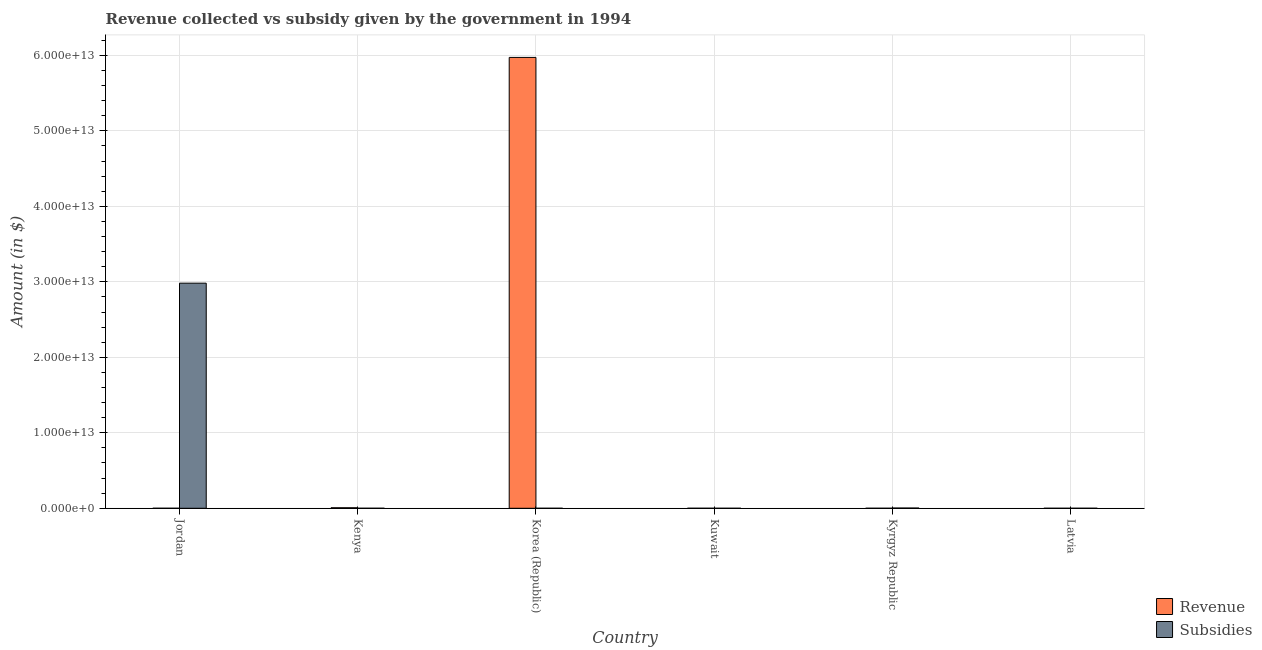How many different coloured bars are there?
Provide a succinct answer. 2. How many groups of bars are there?
Give a very brief answer. 6. What is the label of the 2nd group of bars from the left?
Your answer should be very brief. Kenya. In how many cases, is the number of bars for a given country not equal to the number of legend labels?
Offer a very short reply. 0. What is the amount of subsidies given in Korea (Republic)?
Provide a succinct answer. 3.35e+08. Across all countries, what is the maximum amount of subsidies given?
Provide a short and direct response. 2.98e+13. In which country was the amount of subsidies given maximum?
Make the answer very short. Jordan. In which country was the amount of subsidies given minimum?
Make the answer very short. Kuwait. What is the total amount of revenue collected in the graph?
Keep it short and to the point. 5.98e+13. What is the difference between the amount of subsidies given in Kuwait and that in Latvia?
Ensure brevity in your answer.  -5.97e+08. What is the difference between the amount of revenue collected in Jordan and the amount of subsidies given in Latvia?
Ensure brevity in your answer.  5.57e+08. What is the average amount of subsidies given per country?
Provide a succinct answer. 4.98e+12. What is the difference between the amount of revenue collected and amount of subsidies given in Kuwait?
Offer a terse response. 2.54e+09. In how many countries, is the amount of revenue collected greater than 34000000000000 $?
Offer a very short reply. 1. What is the ratio of the amount of revenue collected in Jordan to that in Kyrgyz Republic?
Ensure brevity in your answer.  0.62. Is the difference between the amount of subsidies given in Kenya and Korea (Republic) greater than the difference between the amount of revenue collected in Kenya and Korea (Republic)?
Ensure brevity in your answer.  Yes. What is the difference between the highest and the second highest amount of subsidies given?
Your answer should be compact. 2.98e+13. What is the difference between the highest and the lowest amount of revenue collected?
Ensure brevity in your answer.  5.97e+13. In how many countries, is the amount of revenue collected greater than the average amount of revenue collected taken over all countries?
Offer a very short reply. 1. Is the sum of the amount of revenue collected in Korea (Republic) and Kuwait greater than the maximum amount of subsidies given across all countries?
Offer a terse response. Yes. What does the 1st bar from the left in Kyrgyz Republic represents?
Provide a succinct answer. Revenue. What does the 2nd bar from the right in Latvia represents?
Provide a short and direct response. Revenue. Are all the bars in the graph horizontal?
Offer a very short reply. No. What is the difference between two consecutive major ticks on the Y-axis?
Your response must be concise. 1.00e+13. Does the graph contain grids?
Your response must be concise. Yes. How many legend labels are there?
Provide a succinct answer. 2. How are the legend labels stacked?
Your answer should be very brief. Vertical. What is the title of the graph?
Your answer should be very brief. Revenue collected vs subsidy given by the government in 1994. Does "Drinking water services" appear as one of the legend labels in the graph?
Your response must be concise. No. What is the label or title of the X-axis?
Give a very brief answer. Country. What is the label or title of the Y-axis?
Give a very brief answer. Amount (in $). What is the Amount (in $) in Revenue in Jordan?
Give a very brief answer. 1.16e+09. What is the Amount (in $) of Subsidies in Jordan?
Make the answer very short. 2.98e+13. What is the Amount (in $) in Revenue in Kenya?
Offer a terse response. 6.74e+1. What is the Amount (in $) of Subsidies in Kenya?
Keep it short and to the point. 8.19e+08. What is the Amount (in $) in Revenue in Korea (Republic)?
Keep it short and to the point. 5.97e+13. What is the Amount (in $) of Subsidies in Korea (Republic)?
Make the answer very short. 3.35e+08. What is the Amount (in $) of Revenue in Kuwait?
Make the answer very short. 2.54e+09. What is the Amount (in $) of Revenue in Kyrgyz Republic?
Provide a succinct answer. 1.87e+09. What is the Amount (in $) of Subsidies in Kyrgyz Republic?
Make the answer very short. 3.03e+1. What is the Amount (in $) in Revenue in Latvia?
Make the answer very short. 5.22e+08. What is the Amount (in $) in Subsidies in Latvia?
Make the answer very short. 6.05e+08. Across all countries, what is the maximum Amount (in $) in Revenue?
Provide a succinct answer. 5.97e+13. Across all countries, what is the maximum Amount (in $) of Subsidies?
Your answer should be compact. 2.98e+13. Across all countries, what is the minimum Amount (in $) in Revenue?
Make the answer very short. 5.22e+08. What is the total Amount (in $) in Revenue in the graph?
Provide a short and direct response. 5.98e+13. What is the total Amount (in $) of Subsidies in the graph?
Provide a succinct answer. 2.99e+13. What is the difference between the Amount (in $) of Revenue in Jordan and that in Kenya?
Your response must be concise. -6.62e+1. What is the difference between the Amount (in $) in Subsidies in Jordan and that in Kenya?
Your response must be concise. 2.98e+13. What is the difference between the Amount (in $) in Revenue in Jordan and that in Korea (Republic)?
Give a very brief answer. -5.97e+13. What is the difference between the Amount (in $) of Subsidies in Jordan and that in Korea (Republic)?
Offer a terse response. 2.98e+13. What is the difference between the Amount (in $) in Revenue in Jordan and that in Kuwait?
Give a very brief answer. -1.38e+09. What is the difference between the Amount (in $) in Subsidies in Jordan and that in Kuwait?
Offer a very short reply. 2.98e+13. What is the difference between the Amount (in $) in Revenue in Jordan and that in Kyrgyz Republic?
Give a very brief answer. -7.10e+08. What is the difference between the Amount (in $) of Subsidies in Jordan and that in Kyrgyz Republic?
Provide a succinct answer. 2.98e+13. What is the difference between the Amount (in $) of Revenue in Jordan and that in Latvia?
Give a very brief answer. 6.40e+08. What is the difference between the Amount (in $) of Subsidies in Jordan and that in Latvia?
Ensure brevity in your answer.  2.98e+13. What is the difference between the Amount (in $) of Revenue in Kenya and that in Korea (Republic)?
Ensure brevity in your answer.  -5.97e+13. What is the difference between the Amount (in $) of Subsidies in Kenya and that in Korea (Republic)?
Keep it short and to the point. 4.84e+08. What is the difference between the Amount (in $) in Revenue in Kenya and that in Kuwait?
Ensure brevity in your answer.  6.48e+1. What is the difference between the Amount (in $) in Subsidies in Kenya and that in Kuwait?
Keep it short and to the point. 8.11e+08. What is the difference between the Amount (in $) of Revenue in Kenya and that in Kyrgyz Republic?
Keep it short and to the point. 6.55e+1. What is the difference between the Amount (in $) of Subsidies in Kenya and that in Kyrgyz Republic?
Your response must be concise. -2.94e+1. What is the difference between the Amount (in $) of Revenue in Kenya and that in Latvia?
Offer a very short reply. 6.68e+1. What is the difference between the Amount (in $) in Subsidies in Kenya and that in Latvia?
Keep it short and to the point. 2.14e+08. What is the difference between the Amount (in $) in Revenue in Korea (Republic) and that in Kuwait?
Make the answer very short. 5.97e+13. What is the difference between the Amount (in $) in Subsidies in Korea (Republic) and that in Kuwait?
Make the answer very short. 3.27e+08. What is the difference between the Amount (in $) of Revenue in Korea (Republic) and that in Kyrgyz Republic?
Your answer should be very brief. 5.97e+13. What is the difference between the Amount (in $) of Subsidies in Korea (Republic) and that in Kyrgyz Republic?
Your response must be concise. -2.99e+1. What is the difference between the Amount (in $) of Revenue in Korea (Republic) and that in Latvia?
Your response must be concise. 5.97e+13. What is the difference between the Amount (in $) in Subsidies in Korea (Republic) and that in Latvia?
Give a very brief answer. -2.70e+08. What is the difference between the Amount (in $) in Revenue in Kuwait and that in Kyrgyz Republic?
Offer a very short reply. 6.73e+08. What is the difference between the Amount (in $) of Subsidies in Kuwait and that in Kyrgyz Republic?
Make the answer very short. -3.02e+1. What is the difference between the Amount (in $) in Revenue in Kuwait and that in Latvia?
Offer a very short reply. 2.02e+09. What is the difference between the Amount (in $) in Subsidies in Kuwait and that in Latvia?
Provide a succinct answer. -5.97e+08. What is the difference between the Amount (in $) of Revenue in Kyrgyz Republic and that in Latvia?
Provide a succinct answer. 1.35e+09. What is the difference between the Amount (in $) of Subsidies in Kyrgyz Republic and that in Latvia?
Keep it short and to the point. 2.96e+1. What is the difference between the Amount (in $) in Revenue in Jordan and the Amount (in $) in Subsidies in Kenya?
Your answer should be very brief. 3.42e+08. What is the difference between the Amount (in $) in Revenue in Jordan and the Amount (in $) in Subsidies in Korea (Republic)?
Keep it short and to the point. 8.26e+08. What is the difference between the Amount (in $) in Revenue in Jordan and the Amount (in $) in Subsidies in Kuwait?
Your response must be concise. 1.15e+09. What is the difference between the Amount (in $) of Revenue in Jordan and the Amount (in $) of Subsidies in Kyrgyz Republic?
Offer a terse response. -2.91e+1. What is the difference between the Amount (in $) of Revenue in Jordan and the Amount (in $) of Subsidies in Latvia?
Provide a short and direct response. 5.57e+08. What is the difference between the Amount (in $) in Revenue in Kenya and the Amount (in $) in Subsidies in Korea (Republic)?
Provide a short and direct response. 6.70e+1. What is the difference between the Amount (in $) of Revenue in Kenya and the Amount (in $) of Subsidies in Kuwait?
Ensure brevity in your answer.  6.74e+1. What is the difference between the Amount (in $) of Revenue in Kenya and the Amount (in $) of Subsidies in Kyrgyz Republic?
Provide a short and direct response. 3.71e+1. What is the difference between the Amount (in $) of Revenue in Kenya and the Amount (in $) of Subsidies in Latvia?
Your answer should be compact. 6.68e+1. What is the difference between the Amount (in $) of Revenue in Korea (Republic) and the Amount (in $) of Subsidies in Kuwait?
Provide a short and direct response. 5.97e+13. What is the difference between the Amount (in $) of Revenue in Korea (Republic) and the Amount (in $) of Subsidies in Kyrgyz Republic?
Offer a very short reply. 5.97e+13. What is the difference between the Amount (in $) in Revenue in Korea (Republic) and the Amount (in $) in Subsidies in Latvia?
Offer a terse response. 5.97e+13. What is the difference between the Amount (in $) of Revenue in Kuwait and the Amount (in $) of Subsidies in Kyrgyz Republic?
Make the answer very short. -2.77e+1. What is the difference between the Amount (in $) in Revenue in Kuwait and the Amount (in $) in Subsidies in Latvia?
Provide a succinct answer. 1.94e+09. What is the difference between the Amount (in $) in Revenue in Kyrgyz Republic and the Amount (in $) in Subsidies in Latvia?
Offer a terse response. 1.27e+09. What is the average Amount (in $) of Revenue per country?
Make the answer very short. 9.97e+12. What is the average Amount (in $) of Subsidies per country?
Give a very brief answer. 4.98e+12. What is the difference between the Amount (in $) of Revenue and Amount (in $) of Subsidies in Jordan?
Provide a succinct answer. -2.98e+13. What is the difference between the Amount (in $) in Revenue and Amount (in $) in Subsidies in Kenya?
Make the answer very short. 6.65e+1. What is the difference between the Amount (in $) in Revenue and Amount (in $) in Subsidies in Korea (Republic)?
Give a very brief answer. 5.97e+13. What is the difference between the Amount (in $) in Revenue and Amount (in $) in Subsidies in Kuwait?
Give a very brief answer. 2.54e+09. What is the difference between the Amount (in $) of Revenue and Amount (in $) of Subsidies in Kyrgyz Republic?
Make the answer very short. -2.84e+1. What is the difference between the Amount (in $) of Revenue and Amount (in $) of Subsidies in Latvia?
Offer a terse response. -8.32e+07. What is the ratio of the Amount (in $) in Revenue in Jordan to that in Kenya?
Make the answer very short. 0.02. What is the ratio of the Amount (in $) in Subsidies in Jordan to that in Kenya?
Give a very brief answer. 3.64e+04. What is the ratio of the Amount (in $) in Subsidies in Jordan to that in Korea (Republic)?
Ensure brevity in your answer.  8.90e+04. What is the ratio of the Amount (in $) in Revenue in Jordan to that in Kuwait?
Provide a short and direct response. 0.46. What is the ratio of the Amount (in $) of Subsidies in Jordan to that in Kuwait?
Ensure brevity in your answer.  3.73e+06. What is the ratio of the Amount (in $) in Revenue in Jordan to that in Kyrgyz Republic?
Provide a short and direct response. 0.62. What is the ratio of the Amount (in $) in Subsidies in Jordan to that in Kyrgyz Republic?
Offer a terse response. 985.72. What is the ratio of the Amount (in $) in Revenue in Jordan to that in Latvia?
Provide a succinct answer. 2.23. What is the ratio of the Amount (in $) of Subsidies in Jordan to that in Latvia?
Ensure brevity in your answer.  4.93e+04. What is the ratio of the Amount (in $) in Revenue in Kenya to that in Korea (Republic)?
Your response must be concise. 0. What is the ratio of the Amount (in $) in Subsidies in Kenya to that in Korea (Republic)?
Ensure brevity in your answer.  2.44. What is the ratio of the Amount (in $) of Revenue in Kenya to that in Kuwait?
Provide a succinct answer. 26.47. What is the ratio of the Amount (in $) in Subsidies in Kenya to that in Kuwait?
Your answer should be very brief. 102.38. What is the ratio of the Amount (in $) in Revenue in Kenya to that in Kyrgyz Republic?
Make the answer very short. 35.99. What is the ratio of the Amount (in $) in Subsidies in Kenya to that in Kyrgyz Republic?
Offer a terse response. 0.03. What is the ratio of the Amount (in $) of Revenue in Kenya to that in Latvia?
Offer a very short reply. 129.12. What is the ratio of the Amount (in $) of Subsidies in Kenya to that in Latvia?
Offer a terse response. 1.35. What is the ratio of the Amount (in $) of Revenue in Korea (Republic) to that in Kuwait?
Keep it short and to the point. 2.35e+04. What is the ratio of the Amount (in $) of Subsidies in Korea (Republic) to that in Kuwait?
Your response must be concise. 41.87. What is the ratio of the Amount (in $) in Revenue in Korea (Republic) to that in Kyrgyz Republic?
Your response must be concise. 3.19e+04. What is the ratio of the Amount (in $) in Subsidies in Korea (Republic) to that in Kyrgyz Republic?
Ensure brevity in your answer.  0.01. What is the ratio of the Amount (in $) of Revenue in Korea (Republic) to that in Latvia?
Offer a very short reply. 1.14e+05. What is the ratio of the Amount (in $) in Subsidies in Korea (Republic) to that in Latvia?
Make the answer very short. 0.55. What is the ratio of the Amount (in $) of Revenue in Kuwait to that in Kyrgyz Republic?
Your response must be concise. 1.36. What is the ratio of the Amount (in $) of Revenue in Kuwait to that in Latvia?
Your answer should be compact. 4.88. What is the ratio of the Amount (in $) in Subsidies in Kuwait to that in Latvia?
Make the answer very short. 0.01. What is the ratio of the Amount (in $) of Revenue in Kyrgyz Republic to that in Latvia?
Provide a short and direct response. 3.59. What is the ratio of the Amount (in $) of Subsidies in Kyrgyz Republic to that in Latvia?
Your response must be concise. 50.01. What is the difference between the highest and the second highest Amount (in $) in Revenue?
Ensure brevity in your answer.  5.97e+13. What is the difference between the highest and the second highest Amount (in $) in Subsidies?
Make the answer very short. 2.98e+13. What is the difference between the highest and the lowest Amount (in $) of Revenue?
Give a very brief answer. 5.97e+13. What is the difference between the highest and the lowest Amount (in $) of Subsidies?
Offer a very short reply. 2.98e+13. 